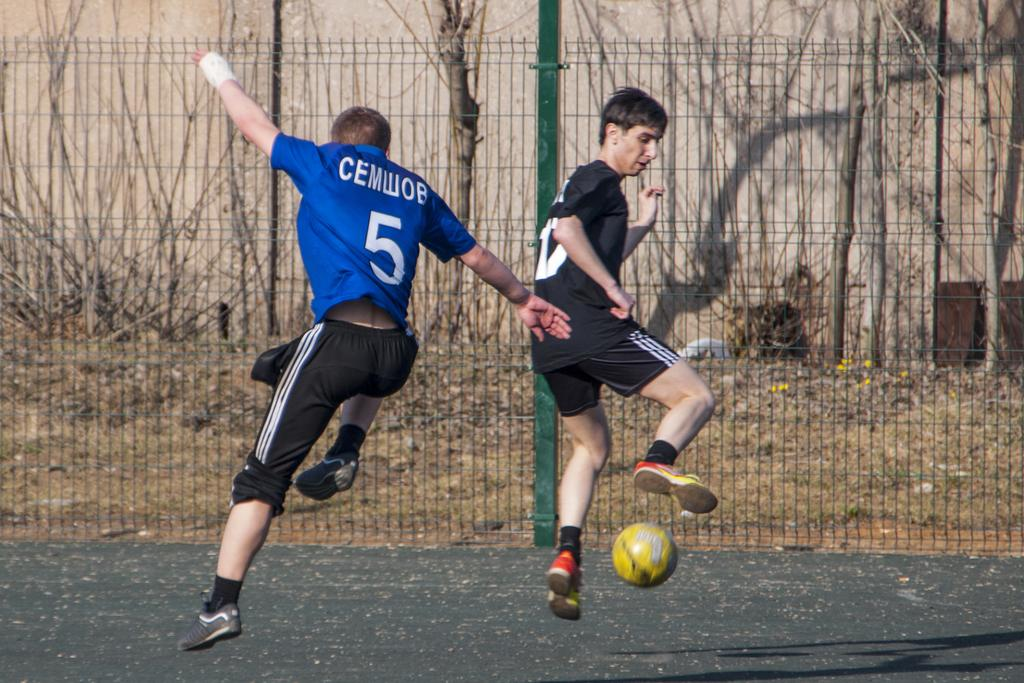<image>
Render a clear and concise summary of the photo. Soccer player in blue shirt with CEMWOB in white letters. 